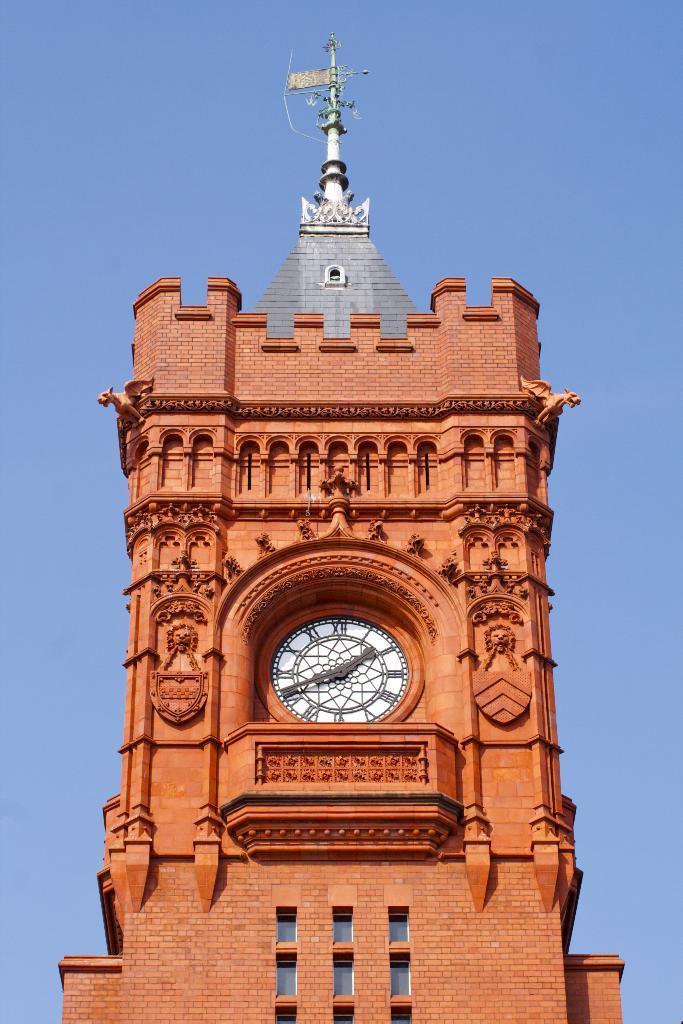Describe this image in one or two sentences. In the image there is a clock tower in the middle with a antenna above it and behind its sky. 